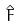Convert formula to latex. <formula><loc_0><loc_0><loc_500><loc_500>\hat { F }</formula> 